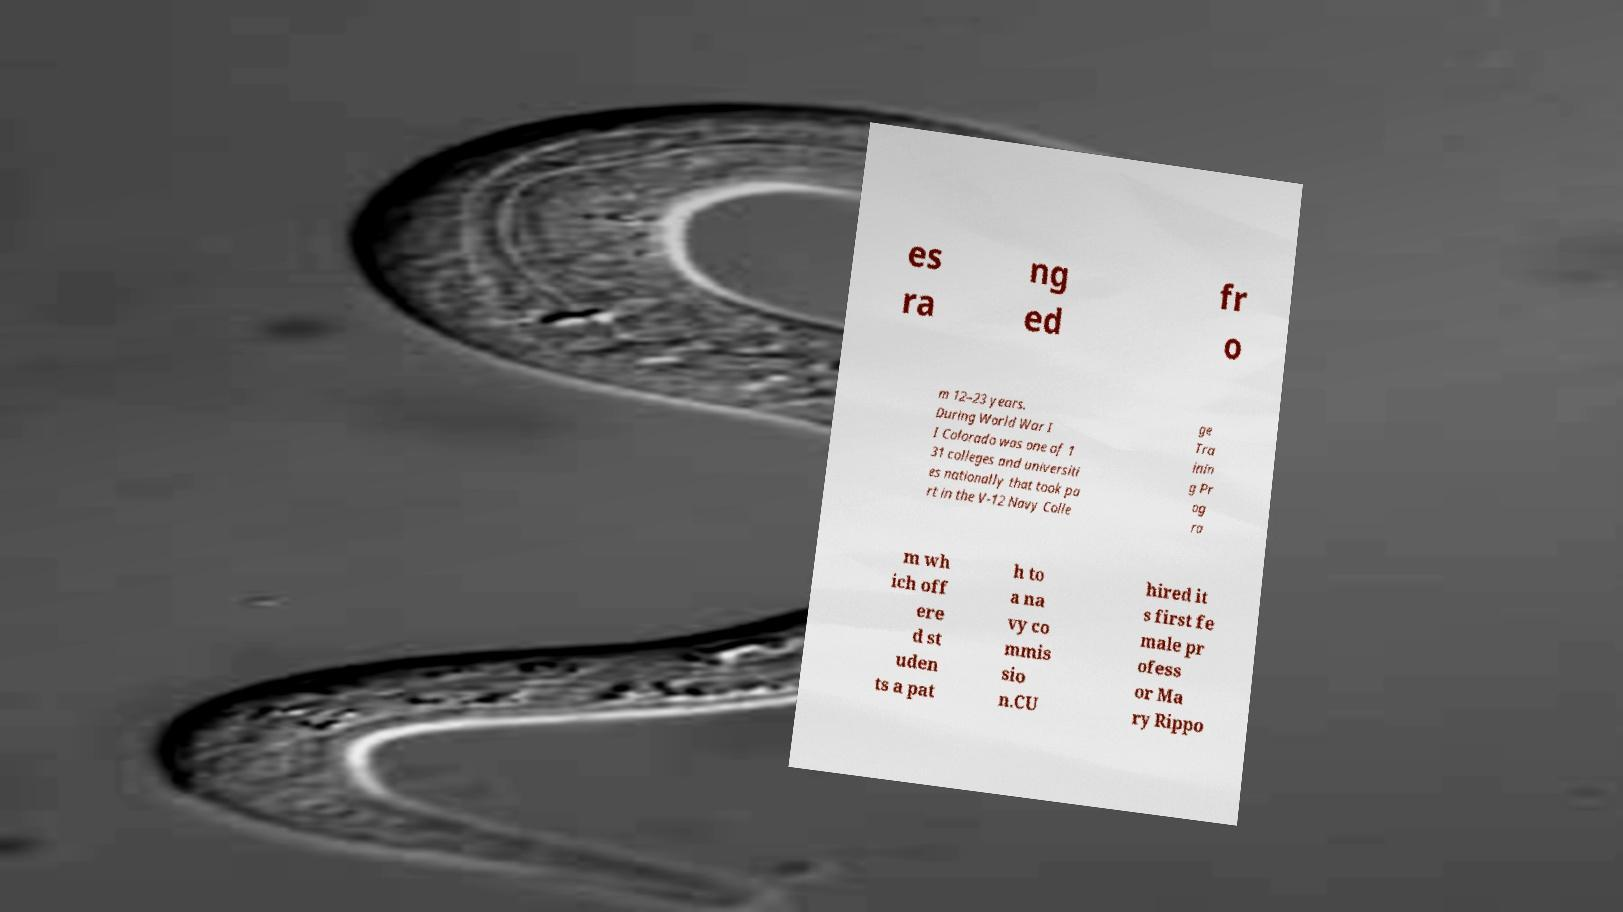Can you read and provide the text displayed in the image?This photo seems to have some interesting text. Can you extract and type it out for me? es ra ng ed fr o m 12–23 years. During World War I I Colorado was one of 1 31 colleges and universiti es nationally that took pa rt in the V-12 Navy Colle ge Tra inin g Pr og ra m wh ich off ere d st uden ts a pat h to a na vy co mmis sio n.CU hired it s first fe male pr ofess or Ma ry Rippo 